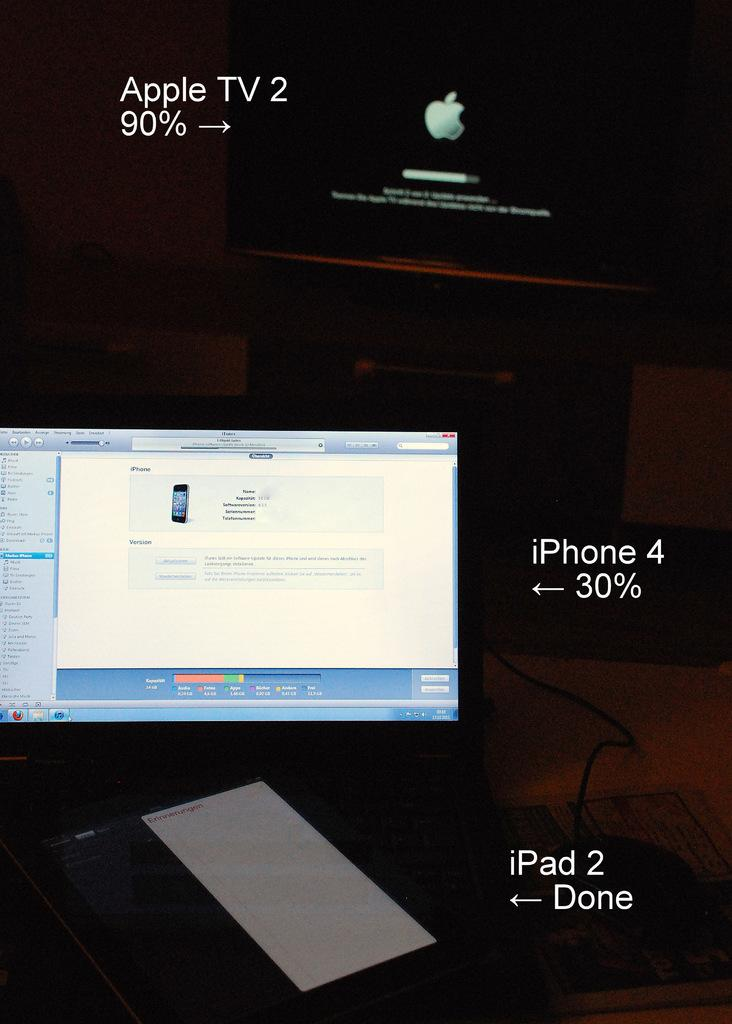<image>
Describe the image concisely. A picture of apple devices with one saying iphone 30%. 